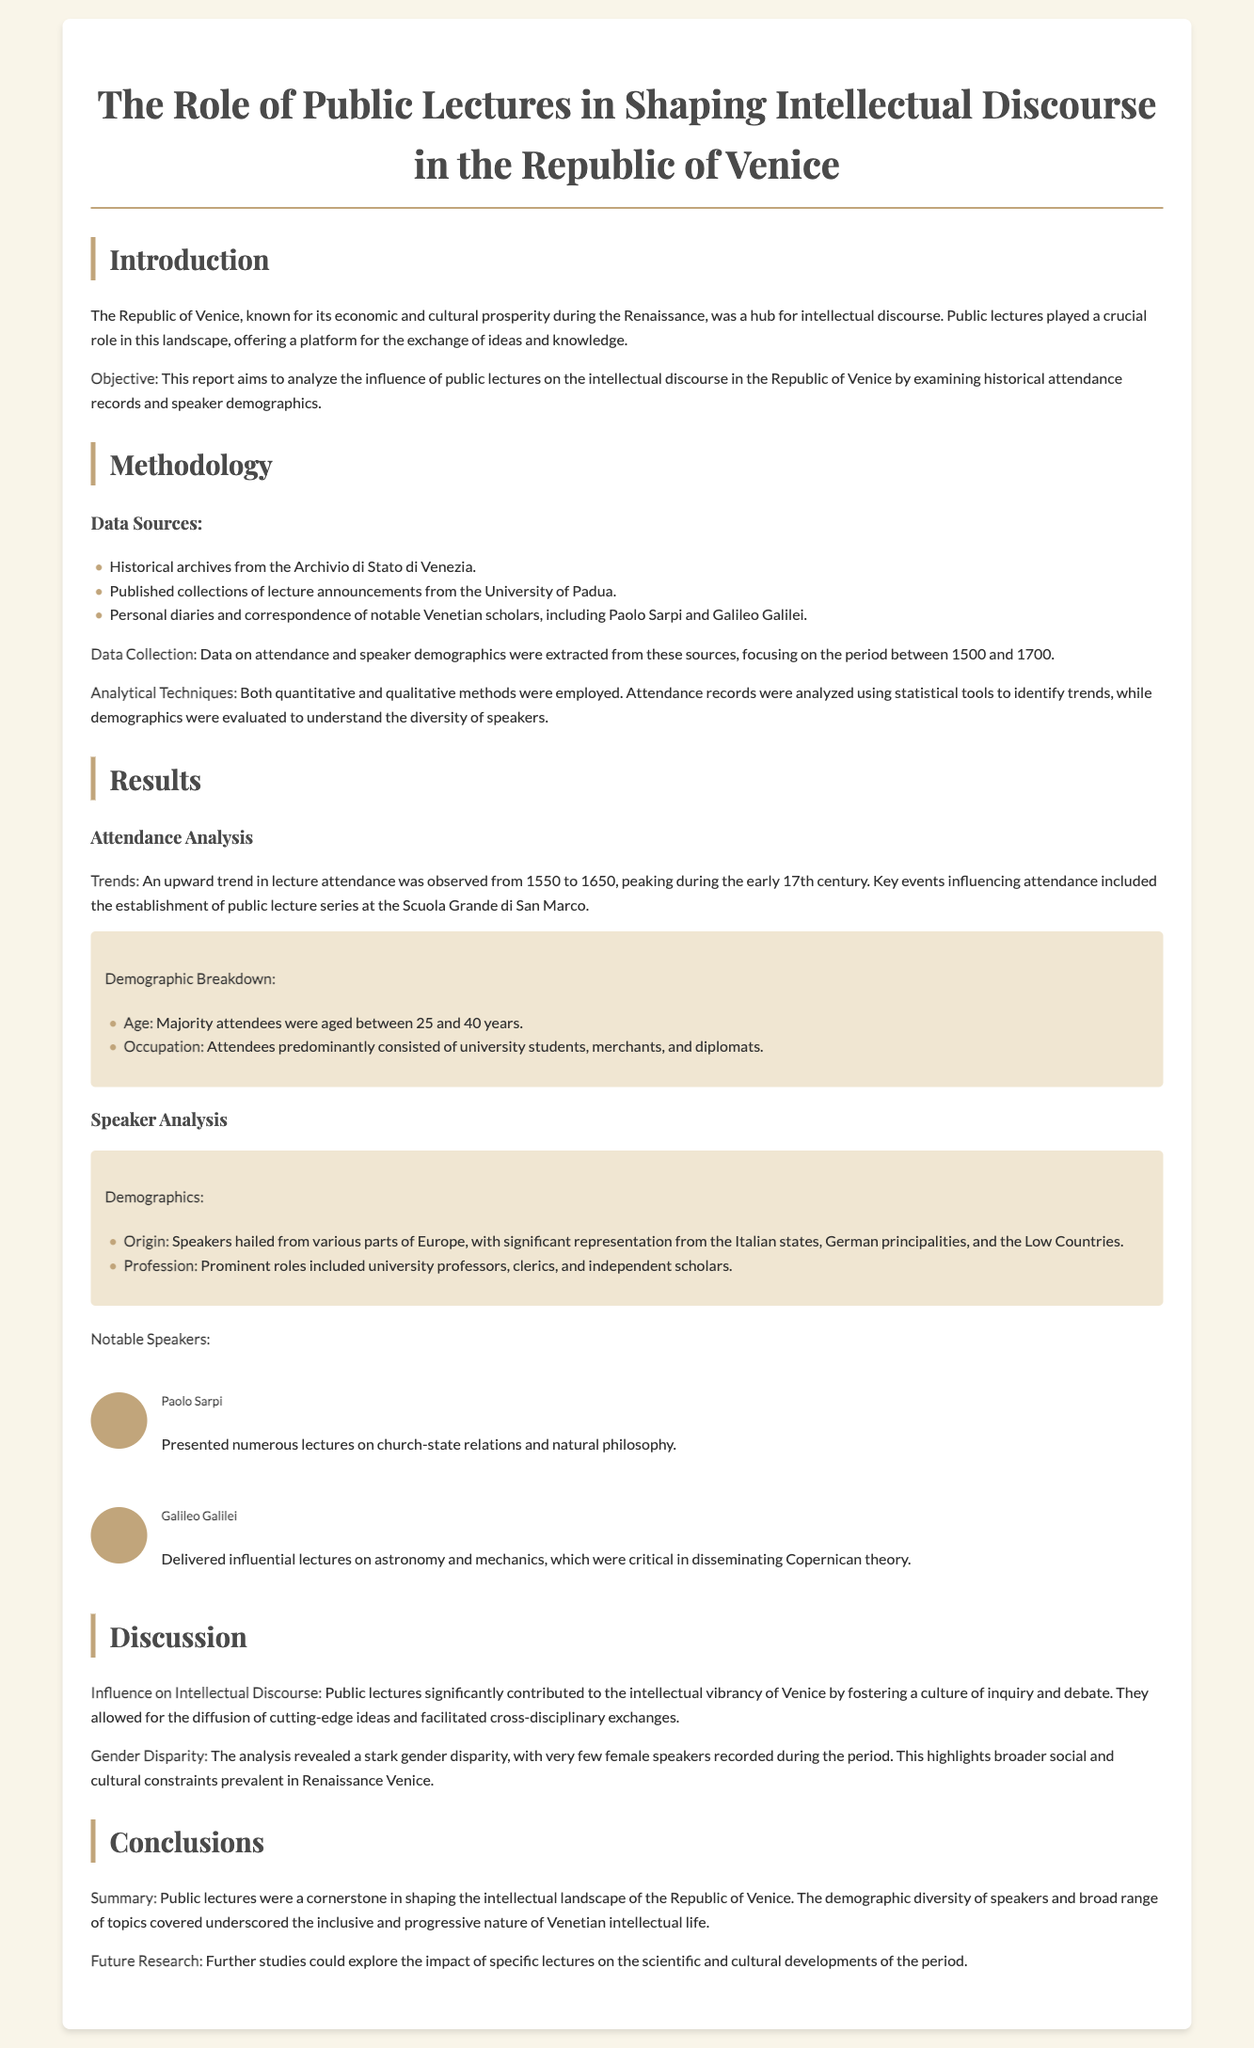what was the primary objective of the report? The objective of the report is to analyze the influence of public lectures on the intellectual discourse in the Republic of Venice.
Answer: analyze the influence of public lectures which archives were used as data sources? Data sources included historical archives from the Archivio di Stato di Venezia.
Answer: Archivio di Stato di Venezia what years does the attendance data focus on? The data on attendance was focused on the period between 1500 and 1700.
Answer: 1500 to 1700 who delivered influential lectures on astronomy? Galileo Galilei is mentioned as the one who delivered influential lectures on astronomy.
Answer: Galileo Galilei what significant trend was observed in attendance from 1550 to 1650? An upward trend in lecture attendance was observed during this period.
Answer: upward trend what was a notable demographic characteristic of the majority of attendees? The majority of attendees were aged between 25 and 40 years.
Answer: aged between 25 and 40 how many female speakers were recorded during the period? The report indicated very few female speakers were recorded.
Answer: very few what type of roles did prominent speakers hold? Prominent roles included university professors, clerics, and independent scholars.
Answer: university professors, clerics, independent scholars what future research suggestion is mentioned in the report? Further studies could explore the impact of specific lectures on scientific and cultural developments.
Answer: impact of specific lectures on scientific and cultural developments 